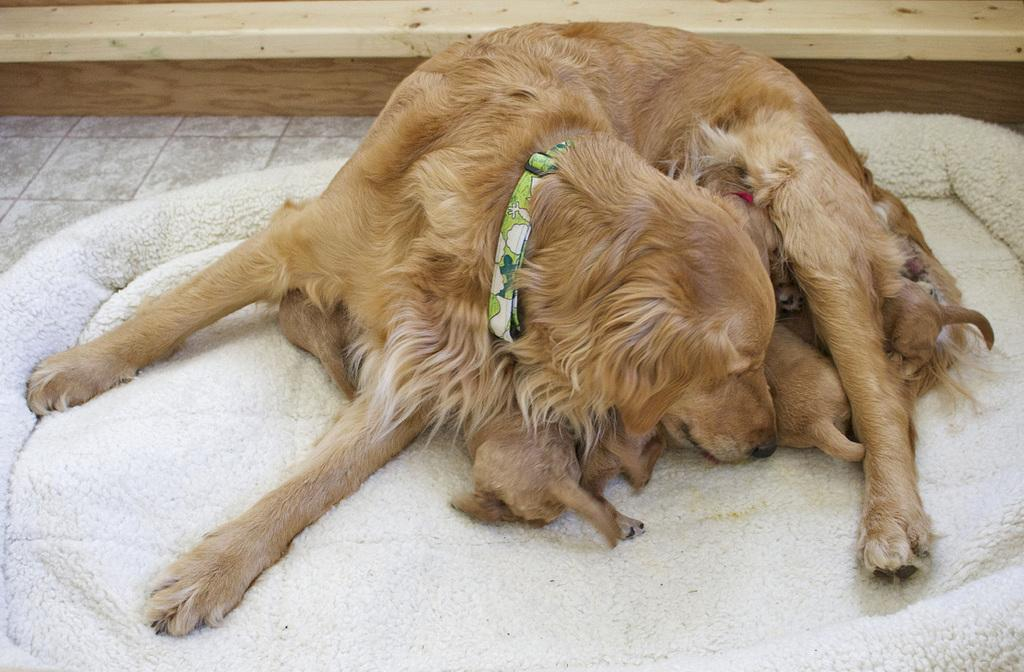What type of animal is present in the image? There is a dog in the image. Are there any other animals in the image? Yes, there are puppies in the image. What is located at the bottom of the image? There is a mat at the bottom of the image. What is attached to the dog's neck? There is a strap on the dog's neck. What type of wire is the beggar using to communicate with the dog in the image? There is no beggar or wire present in the image; it features a dog and puppies on a mat with a strap on the dog's neck. What type of home is depicted in the image? The image does not depict a home; it features a dog, puppies, a mat, and a strap on the dog's neck. 